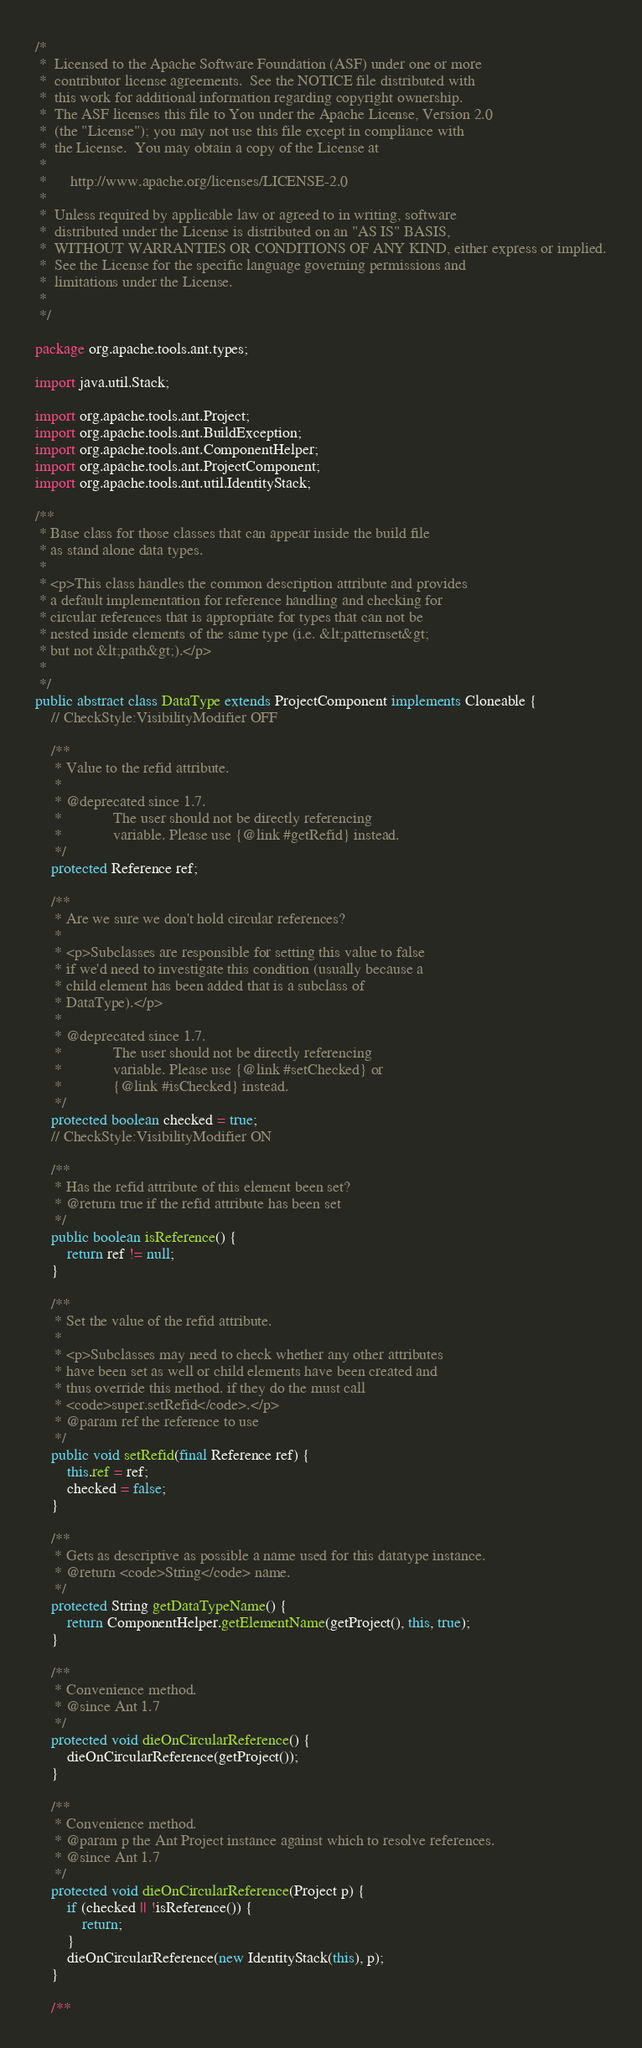<code> <loc_0><loc_0><loc_500><loc_500><_Java_>/*
 *  Licensed to the Apache Software Foundation (ASF) under one or more
 *  contributor license agreements.  See the NOTICE file distributed with
 *  this work for additional information regarding copyright ownership.
 *  The ASF licenses this file to You under the Apache License, Version 2.0
 *  (the "License"); you may not use this file except in compliance with
 *  the License.  You may obtain a copy of the License at
 *
 *      http://www.apache.org/licenses/LICENSE-2.0
 *
 *  Unless required by applicable law or agreed to in writing, software
 *  distributed under the License is distributed on an "AS IS" BASIS,
 *  WITHOUT WARRANTIES OR CONDITIONS OF ANY KIND, either express or implied.
 *  See the License for the specific language governing permissions and
 *  limitations under the License.
 *
 */

package org.apache.tools.ant.types;

import java.util.Stack;

import org.apache.tools.ant.Project;
import org.apache.tools.ant.BuildException;
import org.apache.tools.ant.ComponentHelper;
import org.apache.tools.ant.ProjectComponent;
import org.apache.tools.ant.util.IdentityStack;

/**
 * Base class for those classes that can appear inside the build file
 * as stand alone data types.
 *
 * <p>This class handles the common description attribute and provides
 * a default implementation for reference handling and checking for
 * circular references that is appropriate for types that can not be
 * nested inside elements of the same type (i.e. &lt;patternset&gt;
 * but not &lt;path&gt;).</p>
 *
 */
public abstract class DataType extends ProjectComponent implements Cloneable {
    // CheckStyle:VisibilityModifier OFF

    /**
     * Value to the refid attribute.
     *
     * @deprecated since 1.7.
     *             The user should not be directly referencing
     *             variable. Please use {@link #getRefid} instead.
     */
    protected Reference ref;

    /**
     * Are we sure we don't hold circular references?
     *
     * <p>Subclasses are responsible for setting this value to false
     * if we'd need to investigate this condition (usually because a
     * child element has been added that is a subclass of
     * DataType).</p>
     *
     * @deprecated since 1.7.
     *             The user should not be directly referencing
     *             variable. Please use {@link #setChecked} or
     *             {@link #isChecked} instead.
     */
    protected boolean checked = true;
    // CheckStyle:VisibilityModifier ON

    /**
     * Has the refid attribute of this element been set?
     * @return true if the refid attribute has been set
     */
    public boolean isReference() {
        return ref != null;
    }

    /**
     * Set the value of the refid attribute.
     *
     * <p>Subclasses may need to check whether any other attributes
     * have been set as well or child elements have been created and
     * thus override this method. if they do the must call
     * <code>super.setRefid</code>.</p>
     * @param ref the reference to use
     */
    public void setRefid(final Reference ref) {
        this.ref = ref;
        checked = false;
    }

    /**
     * Gets as descriptive as possible a name used for this datatype instance.
     * @return <code>String</code> name.
     */
    protected String getDataTypeName() {
        return ComponentHelper.getElementName(getProject(), this, true);
    }

    /**
     * Convenience method.
     * @since Ant 1.7
     */
    protected void dieOnCircularReference() {
        dieOnCircularReference(getProject());
    }

    /**
     * Convenience method.
     * @param p the Ant Project instance against which to resolve references.
     * @since Ant 1.7
     */
    protected void dieOnCircularReference(Project p) {
        if (checked || !isReference()) {
            return;
        }
        dieOnCircularReference(new IdentityStack(this), p);
    }

    /**</code> 